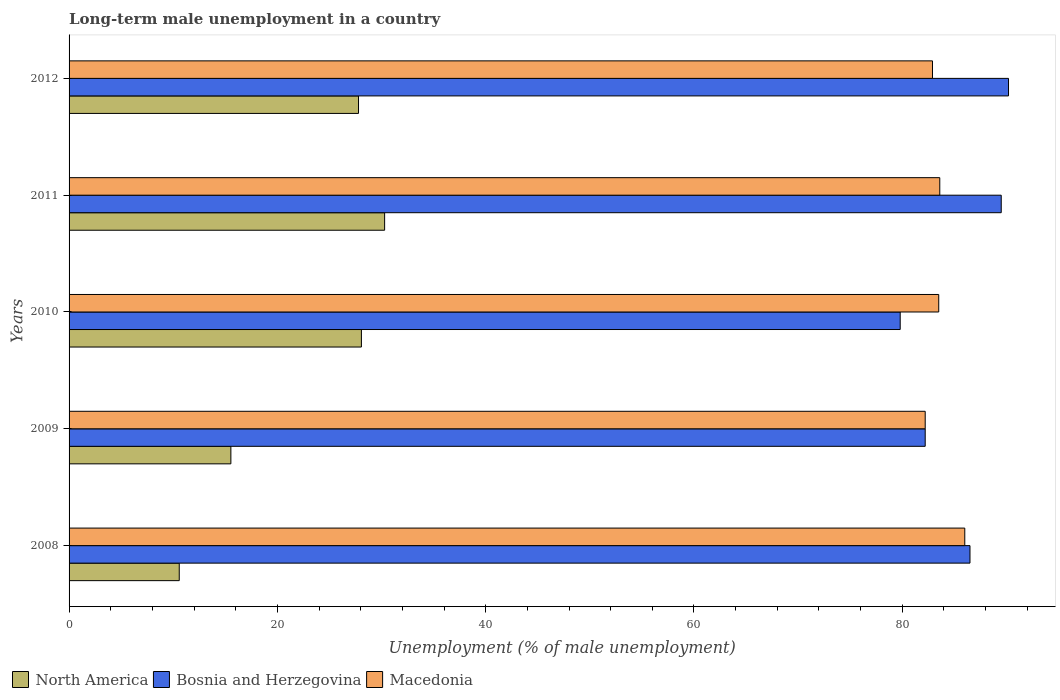What is the label of the 3rd group of bars from the top?
Your answer should be very brief. 2010. What is the percentage of long-term unemployed male population in Bosnia and Herzegovina in 2011?
Ensure brevity in your answer.  89.5. Across all years, what is the maximum percentage of long-term unemployed male population in North America?
Your answer should be very brief. 30.3. Across all years, what is the minimum percentage of long-term unemployed male population in Bosnia and Herzegovina?
Your answer should be very brief. 79.8. In which year was the percentage of long-term unemployed male population in North America maximum?
Keep it short and to the point. 2011. What is the total percentage of long-term unemployed male population in Macedonia in the graph?
Provide a succinct answer. 418.2. What is the difference between the percentage of long-term unemployed male population in Bosnia and Herzegovina in 2010 and that in 2011?
Ensure brevity in your answer.  -9.7. What is the difference between the percentage of long-term unemployed male population in North America in 2010 and the percentage of long-term unemployed male population in Macedonia in 2008?
Offer a terse response. -57.93. What is the average percentage of long-term unemployed male population in Macedonia per year?
Ensure brevity in your answer.  83.64. In the year 2011, what is the difference between the percentage of long-term unemployed male population in Bosnia and Herzegovina and percentage of long-term unemployed male population in Macedonia?
Ensure brevity in your answer.  5.9. What is the ratio of the percentage of long-term unemployed male population in North America in 2009 to that in 2010?
Make the answer very short. 0.55. Is the percentage of long-term unemployed male population in Bosnia and Herzegovina in 2009 less than that in 2012?
Your response must be concise. Yes. What is the difference between the highest and the second highest percentage of long-term unemployed male population in North America?
Offer a very short reply. 2.23. What is the difference between the highest and the lowest percentage of long-term unemployed male population in North America?
Your response must be concise. 19.72. In how many years, is the percentage of long-term unemployed male population in Bosnia and Herzegovina greater than the average percentage of long-term unemployed male population in Bosnia and Herzegovina taken over all years?
Keep it short and to the point. 3. Is the sum of the percentage of long-term unemployed male population in Macedonia in 2008 and 2010 greater than the maximum percentage of long-term unemployed male population in Bosnia and Herzegovina across all years?
Make the answer very short. Yes. What does the 3rd bar from the top in 2012 represents?
Provide a succinct answer. North America. What does the 3rd bar from the bottom in 2010 represents?
Offer a terse response. Macedonia. What is the difference between two consecutive major ticks on the X-axis?
Provide a succinct answer. 20. Are the values on the major ticks of X-axis written in scientific E-notation?
Offer a very short reply. No. Does the graph contain grids?
Your answer should be compact. No. Where does the legend appear in the graph?
Make the answer very short. Bottom left. What is the title of the graph?
Offer a terse response. Long-term male unemployment in a country. Does "Israel" appear as one of the legend labels in the graph?
Your answer should be very brief. No. What is the label or title of the X-axis?
Make the answer very short. Unemployment (% of male unemployment). What is the Unemployment (% of male unemployment) of North America in 2008?
Provide a short and direct response. 10.58. What is the Unemployment (% of male unemployment) in Bosnia and Herzegovina in 2008?
Keep it short and to the point. 86.5. What is the Unemployment (% of male unemployment) in North America in 2009?
Your response must be concise. 15.54. What is the Unemployment (% of male unemployment) of Bosnia and Herzegovina in 2009?
Ensure brevity in your answer.  82.2. What is the Unemployment (% of male unemployment) in Macedonia in 2009?
Provide a succinct answer. 82.2. What is the Unemployment (% of male unemployment) of North America in 2010?
Make the answer very short. 28.07. What is the Unemployment (% of male unemployment) of Bosnia and Herzegovina in 2010?
Provide a short and direct response. 79.8. What is the Unemployment (% of male unemployment) in Macedonia in 2010?
Your answer should be very brief. 83.5. What is the Unemployment (% of male unemployment) of North America in 2011?
Make the answer very short. 30.3. What is the Unemployment (% of male unemployment) of Bosnia and Herzegovina in 2011?
Provide a succinct answer. 89.5. What is the Unemployment (% of male unemployment) in Macedonia in 2011?
Keep it short and to the point. 83.6. What is the Unemployment (% of male unemployment) in North America in 2012?
Keep it short and to the point. 27.79. What is the Unemployment (% of male unemployment) in Bosnia and Herzegovina in 2012?
Offer a very short reply. 90.2. What is the Unemployment (% of male unemployment) of Macedonia in 2012?
Make the answer very short. 82.9. Across all years, what is the maximum Unemployment (% of male unemployment) of North America?
Give a very brief answer. 30.3. Across all years, what is the maximum Unemployment (% of male unemployment) of Bosnia and Herzegovina?
Provide a succinct answer. 90.2. Across all years, what is the minimum Unemployment (% of male unemployment) in North America?
Offer a terse response. 10.58. Across all years, what is the minimum Unemployment (% of male unemployment) in Bosnia and Herzegovina?
Your response must be concise. 79.8. Across all years, what is the minimum Unemployment (% of male unemployment) of Macedonia?
Give a very brief answer. 82.2. What is the total Unemployment (% of male unemployment) in North America in the graph?
Your answer should be very brief. 112.27. What is the total Unemployment (% of male unemployment) in Bosnia and Herzegovina in the graph?
Offer a very short reply. 428.2. What is the total Unemployment (% of male unemployment) of Macedonia in the graph?
Provide a short and direct response. 418.2. What is the difference between the Unemployment (% of male unemployment) of North America in 2008 and that in 2009?
Provide a short and direct response. -4.96. What is the difference between the Unemployment (% of male unemployment) in Macedonia in 2008 and that in 2009?
Your response must be concise. 3.8. What is the difference between the Unemployment (% of male unemployment) of North America in 2008 and that in 2010?
Offer a very short reply. -17.49. What is the difference between the Unemployment (% of male unemployment) of North America in 2008 and that in 2011?
Give a very brief answer. -19.72. What is the difference between the Unemployment (% of male unemployment) of Macedonia in 2008 and that in 2011?
Make the answer very short. 2.4. What is the difference between the Unemployment (% of male unemployment) of North America in 2008 and that in 2012?
Give a very brief answer. -17.21. What is the difference between the Unemployment (% of male unemployment) in North America in 2009 and that in 2010?
Give a very brief answer. -12.53. What is the difference between the Unemployment (% of male unemployment) of Bosnia and Herzegovina in 2009 and that in 2010?
Your answer should be compact. 2.4. What is the difference between the Unemployment (% of male unemployment) of Macedonia in 2009 and that in 2010?
Provide a short and direct response. -1.3. What is the difference between the Unemployment (% of male unemployment) of North America in 2009 and that in 2011?
Provide a succinct answer. -14.76. What is the difference between the Unemployment (% of male unemployment) of Macedonia in 2009 and that in 2011?
Offer a terse response. -1.4. What is the difference between the Unemployment (% of male unemployment) in North America in 2009 and that in 2012?
Offer a very short reply. -12.26. What is the difference between the Unemployment (% of male unemployment) in Bosnia and Herzegovina in 2009 and that in 2012?
Provide a short and direct response. -8. What is the difference between the Unemployment (% of male unemployment) of Macedonia in 2009 and that in 2012?
Your answer should be compact. -0.7. What is the difference between the Unemployment (% of male unemployment) in North America in 2010 and that in 2011?
Keep it short and to the point. -2.23. What is the difference between the Unemployment (% of male unemployment) of North America in 2010 and that in 2012?
Give a very brief answer. 0.28. What is the difference between the Unemployment (% of male unemployment) of Bosnia and Herzegovina in 2010 and that in 2012?
Offer a terse response. -10.4. What is the difference between the Unemployment (% of male unemployment) of North America in 2011 and that in 2012?
Give a very brief answer. 2.51. What is the difference between the Unemployment (% of male unemployment) of Bosnia and Herzegovina in 2011 and that in 2012?
Your answer should be compact. -0.7. What is the difference between the Unemployment (% of male unemployment) of Macedonia in 2011 and that in 2012?
Give a very brief answer. 0.7. What is the difference between the Unemployment (% of male unemployment) in North America in 2008 and the Unemployment (% of male unemployment) in Bosnia and Herzegovina in 2009?
Offer a very short reply. -71.62. What is the difference between the Unemployment (% of male unemployment) in North America in 2008 and the Unemployment (% of male unemployment) in Macedonia in 2009?
Offer a very short reply. -71.62. What is the difference between the Unemployment (% of male unemployment) in Bosnia and Herzegovina in 2008 and the Unemployment (% of male unemployment) in Macedonia in 2009?
Make the answer very short. 4.3. What is the difference between the Unemployment (% of male unemployment) of North America in 2008 and the Unemployment (% of male unemployment) of Bosnia and Herzegovina in 2010?
Give a very brief answer. -69.22. What is the difference between the Unemployment (% of male unemployment) of North America in 2008 and the Unemployment (% of male unemployment) of Macedonia in 2010?
Make the answer very short. -72.92. What is the difference between the Unemployment (% of male unemployment) in Bosnia and Herzegovina in 2008 and the Unemployment (% of male unemployment) in Macedonia in 2010?
Offer a very short reply. 3. What is the difference between the Unemployment (% of male unemployment) of North America in 2008 and the Unemployment (% of male unemployment) of Bosnia and Herzegovina in 2011?
Ensure brevity in your answer.  -78.92. What is the difference between the Unemployment (% of male unemployment) in North America in 2008 and the Unemployment (% of male unemployment) in Macedonia in 2011?
Offer a very short reply. -73.02. What is the difference between the Unemployment (% of male unemployment) in North America in 2008 and the Unemployment (% of male unemployment) in Bosnia and Herzegovina in 2012?
Offer a very short reply. -79.62. What is the difference between the Unemployment (% of male unemployment) of North America in 2008 and the Unemployment (% of male unemployment) of Macedonia in 2012?
Give a very brief answer. -72.32. What is the difference between the Unemployment (% of male unemployment) in North America in 2009 and the Unemployment (% of male unemployment) in Bosnia and Herzegovina in 2010?
Offer a very short reply. -64.27. What is the difference between the Unemployment (% of male unemployment) in North America in 2009 and the Unemployment (% of male unemployment) in Macedonia in 2010?
Offer a terse response. -67.97. What is the difference between the Unemployment (% of male unemployment) in Bosnia and Herzegovina in 2009 and the Unemployment (% of male unemployment) in Macedonia in 2010?
Offer a very short reply. -1.3. What is the difference between the Unemployment (% of male unemployment) of North America in 2009 and the Unemployment (% of male unemployment) of Bosnia and Herzegovina in 2011?
Give a very brief answer. -73.97. What is the difference between the Unemployment (% of male unemployment) in North America in 2009 and the Unemployment (% of male unemployment) in Macedonia in 2011?
Make the answer very short. -68.06. What is the difference between the Unemployment (% of male unemployment) of Bosnia and Herzegovina in 2009 and the Unemployment (% of male unemployment) of Macedonia in 2011?
Give a very brief answer. -1.4. What is the difference between the Unemployment (% of male unemployment) in North America in 2009 and the Unemployment (% of male unemployment) in Bosnia and Herzegovina in 2012?
Ensure brevity in your answer.  -74.67. What is the difference between the Unemployment (% of male unemployment) in North America in 2009 and the Unemployment (% of male unemployment) in Macedonia in 2012?
Keep it short and to the point. -67.36. What is the difference between the Unemployment (% of male unemployment) in Bosnia and Herzegovina in 2009 and the Unemployment (% of male unemployment) in Macedonia in 2012?
Your response must be concise. -0.7. What is the difference between the Unemployment (% of male unemployment) in North America in 2010 and the Unemployment (% of male unemployment) in Bosnia and Herzegovina in 2011?
Make the answer very short. -61.43. What is the difference between the Unemployment (% of male unemployment) in North America in 2010 and the Unemployment (% of male unemployment) in Macedonia in 2011?
Provide a short and direct response. -55.53. What is the difference between the Unemployment (% of male unemployment) in Bosnia and Herzegovina in 2010 and the Unemployment (% of male unemployment) in Macedonia in 2011?
Offer a very short reply. -3.8. What is the difference between the Unemployment (% of male unemployment) of North America in 2010 and the Unemployment (% of male unemployment) of Bosnia and Herzegovina in 2012?
Provide a succinct answer. -62.13. What is the difference between the Unemployment (% of male unemployment) in North America in 2010 and the Unemployment (% of male unemployment) in Macedonia in 2012?
Your answer should be very brief. -54.83. What is the difference between the Unemployment (% of male unemployment) of North America in 2011 and the Unemployment (% of male unemployment) of Bosnia and Herzegovina in 2012?
Ensure brevity in your answer.  -59.9. What is the difference between the Unemployment (% of male unemployment) in North America in 2011 and the Unemployment (% of male unemployment) in Macedonia in 2012?
Ensure brevity in your answer.  -52.6. What is the difference between the Unemployment (% of male unemployment) in Bosnia and Herzegovina in 2011 and the Unemployment (% of male unemployment) in Macedonia in 2012?
Your answer should be compact. 6.6. What is the average Unemployment (% of male unemployment) of North America per year?
Your answer should be compact. 22.45. What is the average Unemployment (% of male unemployment) in Bosnia and Herzegovina per year?
Make the answer very short. 85.64. What is the average Unemployment (% of male unemployment) of Macedonia per year?
Keep it short and to the point. 83.64. In the year 2008, what is the difference between the Unemployment (% of male unemployment) in North America and Unemployment (% of male unemployment) in Bosnia and Herzegovina?
Your answer should be very brief. -75.92. In the year 2008, what is the difference between the Unemployment (% of male unemployment) of North America and Unemployment (% of male unemployment) of Macedonia?
Provide a short and direct response. -75.42. In the year 2008, what is the difference between the Unemployment (% of male unemployment) of Bosnia and Herzegovina and Unemployment (% of male unemployment) of Macedonia?
Keep it short and to the point. 0.5. In the year 2009, what is the difference between the Unemployment (% of male unemployment) of North America and Unemployment (% of male unemployment) of Bosnia and Herzegovina?
Offer a very short reply. -66.67. In the year 2009, what is the difference between the Unemployment (% of male unemployment) of North America and Unemployment (% of male unemployment) of Macedonia?
Keep it short and to the point. -66.67. In the year 2010, what is the difference between the Unemployment (% of male unemployment) in North America and Unemployment (% of male unemployment) in Bosnia and Herzegovina?
Your answer should be compact. -51.73. In the year 2010, what is the difference between the Unemployment (% of male unemployment) in North America and Unemployment (% of male unemployment) in Macedonia?
Provide a succinct answer. -55.43. In the year 2011, what is the difference between the Unemployment (% of male unemployment) of North America and Unemployment (% of male unemployment) of Bosnia and Herzegovina?
Your answer should be very brief. -59.2. In the year 2011, what is the difference between the Unemployment (% of male unemployment) in North America and Unemployment (% of male unemployment) in Macedonia?
Your response must be concise. -53.3. In the year 2012, what is the difference between the Unemployment (% of male unemployment) of North America and Unemployment (% of male unemployment) of Bosnia and Herzegovina?
Keep it short and to the point. -62.41. In the year 2012, what is the difference between the Unemployment (% of male unemployment) in North America and Unemployment (% of male unemployment) in Macedonia?
Offer a terse response. -55.11. In the year 2012, what is the difference between the Unemployment (% of male unemployment) in Bosnia and Herzegovina and Unemployment (% of male unemployment) in Macedonia?
Your response must be concise. 7.3. What is the ratio of the Unemployment (% of male unemployment) in North America in 2008 to that in 2009?
Provide a short and direct response. 0.68. What is the ratio of the Unemployment (% of male unemployment) of Bosnia and Herzegovina in 2008 to that in 2009?
Make the answer very short. 1.05. What is the ratio of the Unemployment (% of male unemployment) in Macedonia in 2008 to that in 2009?
Make the answer very short. 1.05. What is the ratio of the Unemployment (% of male unemployment) in North America in 2008 to that in 2010?
Provide a succinct answer. 0.38. What is the ratio of the Unemployment (% of male unemployment) in Bosnia and Herzegovina in 2008 to that in 2010?
Your response must be concise. 1.08. What is the ratio of the Unemployment (% of male unemployment) of Macedonia in 2008 to that in 2010?
Make the answer very short. 1.03. What is the ratio of the Unemployment (% of male unemployment) of North America in 2008 to that in 2011?
Provide a short and direct response. 0.35. What is the ratio of the Unemployment (% of male unemployment) in Bosnia and Herzegovina in 2008 to that in 2011?
Keep it short and to the point. 0.97. What is the ratio of the Unemployment (% of male unemployment) in Macedonia in 2008 to that in 2011?
Keep it short and to the point. 1.03. What is the ratio of the Unemployment (% of male unemployment) of North America in 2008 to that in 2012?
Offer a very short reply. 0.38. What is the ratio of the Unemployment (% of male unemployment) in Bosnia and Herzegovina in 2008 to that in 2012?
Make the answer very short. 0.96. What is the ratio of the Unemployment (% of male unemployment) in Macedonia in 2008 to that in 2012?
Offer a very short reply. 1.04. What is the ratio of the Unemployment (% of male unemployment) in North America in 2009 to that in 2010?
Your response must be concise. 0.55. What is the ratio of the Unemployment (% of male unemployment) in Bosnia and Herzegovina in 2009 to that in 2010?
Offer a very short reply. 1.03. What is the ratio of the Unemployment (% of male unemployment) in Macedonia in 2009 to that in 2010?
Offer a very short reply. 0.98. What is the ratio of the Unemployment (% of male unemployment) in North America in 2009 to that in 2011?
Make the answer very short. 0.51. What is the ratio of the Unemployment (% of male unemployment) of Bosnia and Herzegovina in 2009 to that in 2011?
Give a very brief answer. 0.92. What is the ratio of the Unemployment (% of male unemployment) of Macedonia in 2009 to that in 2011?
Offer a terse response. 0.98. What is the ratio of the Unemployment (% of male unemployment) in North America in 2009 to that in 2012?
Offer a terse response. 0.56. What is the ratio of the Unemployment (% of male unemployment) in Bosnia and Herzegovina in 2009 to that in 2012?
Offer a very short reply. 0.91. What is the ratio of the Unemployment (% of male unemployment) of North America in 2010 to that in 2011?
Provide a succinct answer. 0.93. What is the ratio of the Unemployment (% of male unemployment) in Bosnia and Herzegovina in 2010 to that in 2011?
Provide a short and direct response. 0.89. What is the ratio of the Unemployment (% of male unemployment) in Bosnia and Herzegovina in 2010 to that in 2012?
Your answer should be very brief. 0.88. What is the ratio of the Unemployment (% of male unemployment) in North America in 2011 to that in 2012?
Give a very brief answer. 1.09. What is the ratio of the Unemployment (% of male unemployment) of Bosnia and Herzegovina in 2011 to that in 2012?
Provide a short and direct response. 0.99. What is the ratio of the Unemployment (% of male unemployment) in Macedonia in 2011 to that in 2012?
Offer a very short reply. 1.01. What is the difference between the highest and the second highest Unemployment (% of male unemployment) in North America?
Your response must be concise. 2.23. What is the difference between the highest and the second highest Unemployment (% of male unemployment) in Macedonia?
Offer a very short reply. 2.4. What is the difference between the highest and the lowest Unemployment (% of male unemployment) of North America?
Make the answer very short. 19.72. 